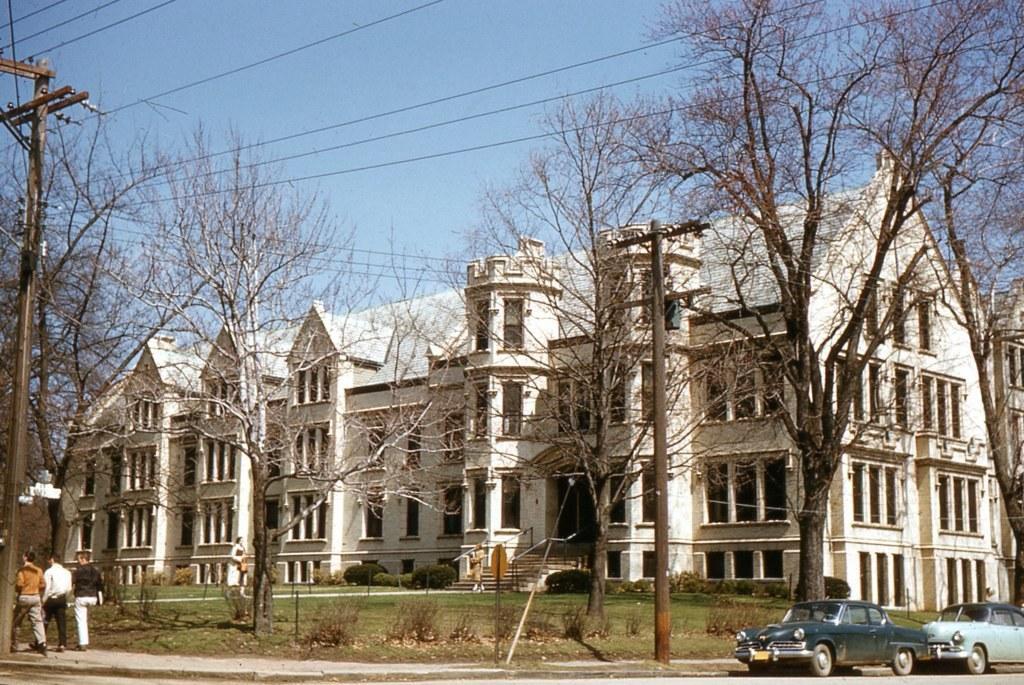Can you describe this image briefly? In this image we can see these cars are parked on the side of the road, these people are walking on the sidewalk, we can see current pole, wires, grass, plants, trees, stairs, buildings and the blue sky in the background. 